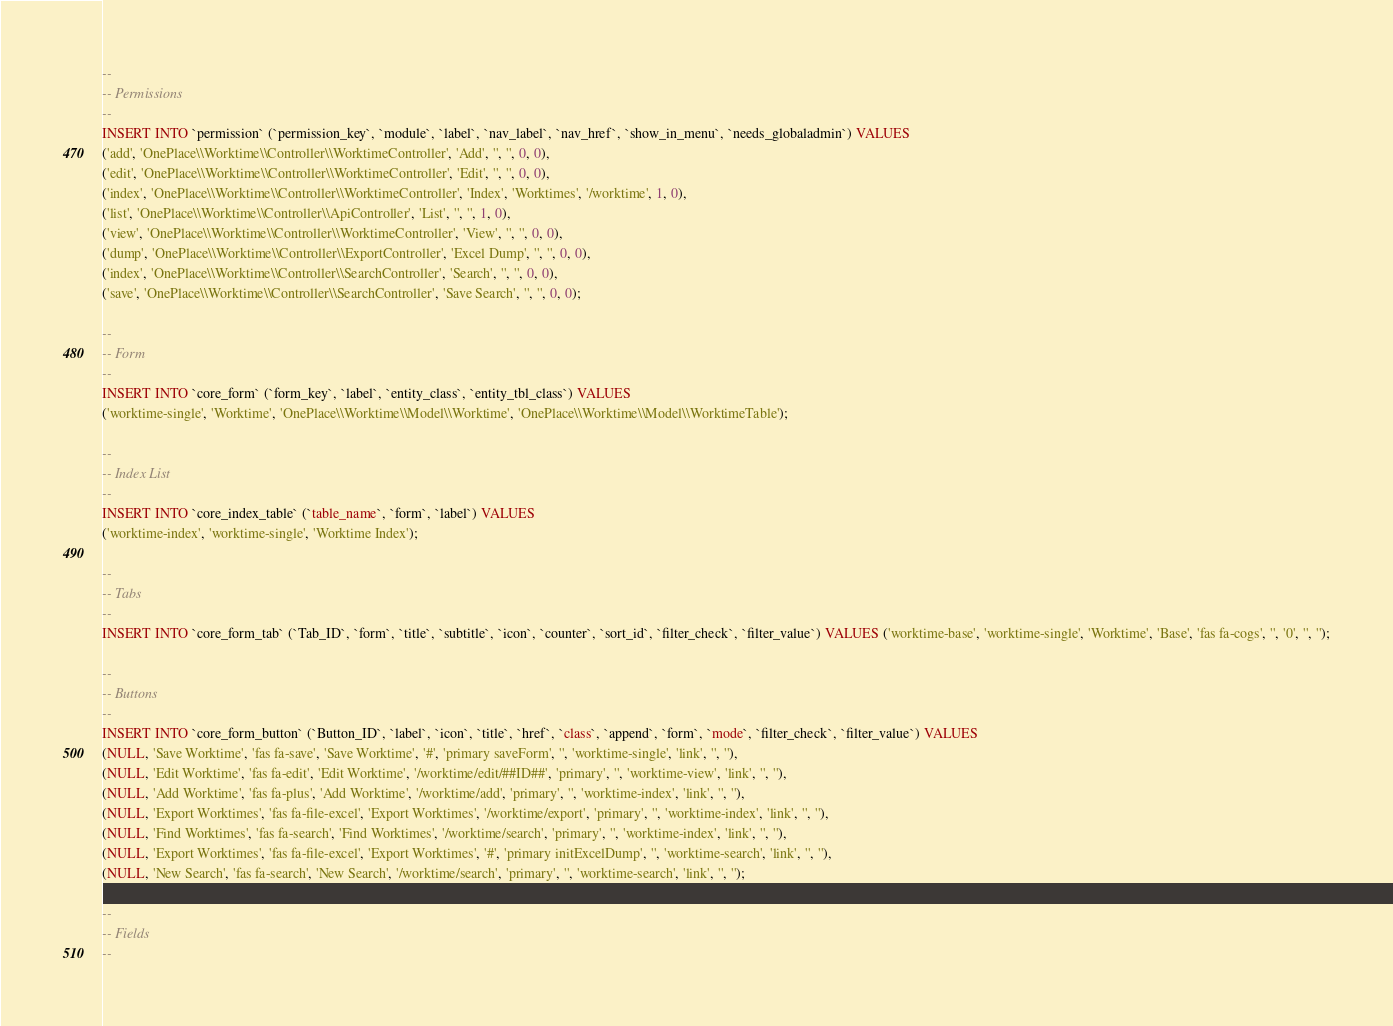Convert code to text. <code><loc_0><loc_0><loc_500><loc_500><_SQL_>
--
-- Permissions
--
INSERT INTO `permission` (`permission_key`, `module`, `label`, `nav_label`, `nav_href`, `show_in_menu`, `needs_globaladmin`) VALUES
('add', 'OnePlace\\Worktime\\Controller\\WorktimeController', 'Add', '', '', 0, 0),
('edit', 'OnePlace\\Worktime\\Controller\\WorktimeController', 'Edit', '', '', 0, 0),
('index', 'OnePlace\\Worktime\\Controller\\WorktimeController', 'Index', 'Worktimes', '/worktime', 1, 0),
('list', 'OnePlace\\Worktime\\Controller\\ApiController', 'List', '', '', 1, 0),
('view', 'OnePlace\\Worktime\\Controller\\WorktimeController', 'View', '', '', 0, 0),
('dump', 'OnePlace\\Worktime\\Controller\\ExportController', 'Excel Dump', '', '', 0, 0),
('index', 'OnePlace\\Worktime\\Controller\\SearchController', 'Search', '', '', 0, 0),
('save', 'OnePlace\\Worktime\\Controller\\SearchController', 'Save Search', '', '', 0, 0);

--
-- Form
--
INSERT INTO `core_form` (`form_key`, `label`, `entity_class`, `entity_tbl_class`) VALUES
('worktime-single', 'Worktime', 'OnePlace\\Worktime\\Model\\Worktime', 'OnePlace\\Worktime\\Model\\WorktimeTable');

--
-- Index List
--
INSERT INTO `core_index_table` (`table_name`, `form`, `label`) VALUES
('worktime-index', 'worktime-single', 'Worktime Index');

--
-- Tabs
--
INSERT INTO `core_form_tab` (`Tab_ID`, `form`, `title`, `subtitle`, `icon`, `counter`, `sort_id`, `filter_check`, `filter_value`) VALUES ('worktime-base', 'worktime-single', 'Worktime', 'Base', 'fas fa-cogs', '', '0', '', '');

--
-- Buttons
--
INSERT INTO `core_form_button` (`Button_ID`, `label`, `icon`, `title`, `href`, `class`, `append`, `form`, `mode`, `filter_check`, `filter_value`) VALUES
(NULL, 'Save Worktime', 'fas fa-save', 'Save Worktime', '#', 'primary saveForm', '', 'worktime-single', 'link', '', ''),
(NULL, 'Edit Worktime', 'fas fa-edit', 'Edit Worktime', '/worktime/edit/##ID##', 'primary', '', 'worktime-view', 'link', '', ''),
(NULL, 'Add Worktime', 'fas fa-plus', 'Add Worktime', '/worktime/add', 'primary', '', 'worktime-index', 'link', '', ''),
(NULL, 'Export Worktimes', 'fas fa-file-excel', 'Export Worktimes', '/worktime/export', 'primary', '', 'worktime-index', 'link', '', ''),
(NULL, 'Find Worktimes', 'fas fa-search', 'Find Worktimes', '/worktime/search', 'primary', '', 'worktime-index', 'link', '', ''),
(NULL, 'Export Worktimes', 'fas fa-file-excel', 'Export Worktimes', '#', 'primary initExcelDump', '', 'worktime-search', 'link', '', ''),
(NULL, 'New Search', 'fas fa-search', 'New Search', '/worktime/search', 'primary', '', 'worktime-search', 'link', '', '');

--
-- Fields
--</code> 